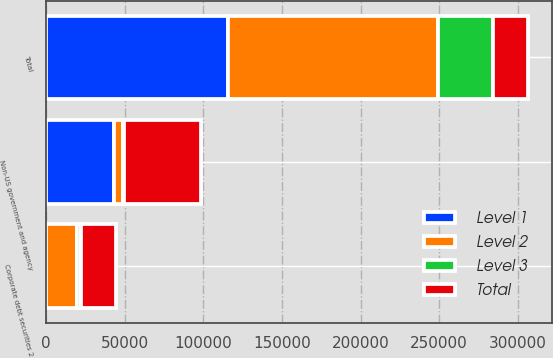<chart> <loc_0><loc_0><loc_500><loc_500><stacked_bar_chart><ecel><fcel>Non-US government and agency<fcel>Corporate debt securities 2<fcel>Total<nl><fcel>Level 1<fcel>42854<fcel>133<fcel>115460<nl><fcel>Level 2<fcel>6203<fcel>19518<fcel>134033<nl><fcel>Level 3<fcel>148<fcel>2480<fcel>34685<nl><fcel>Total<fcel>49205<fcel>22131<fcel>22131<nl></chart> 